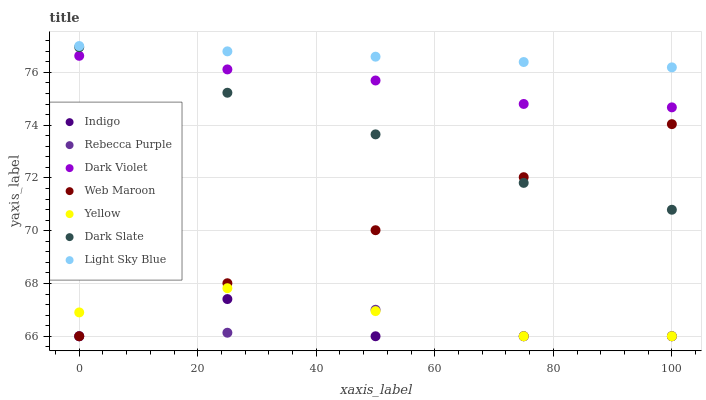Does Rebecca Purple have the minimum area under the curve?
Answer yes or no. Yes. Does Light Sky Blue have the maximum area under the curve?
Answer yes or no. Yes. Does Dark Violet have the minimum area under the curve?
Answer yes or no. No. Does Dark Violet have the maximum area under the curve?
Answer yes or no. No. Is Light Sky Blue the smoothest?
Answer yes or no. Yes. Is Indigo the roughest?
Answer yes or no. Yes. Is Dark Violet the smoothest?
Answer yes or no. No. Is Dark Violet the roughest?
Answer yes or no. No. Does Indigo have the lowest value?
Answer yes or no. Yes. Does Dark Violet have the lowest value?
Answer yes or no. No. Does Light Sky Blue have the highest value?
Answer yes or no. Yes. Does Dark Violet have the highest value?
Answer yes or no. No. Is Yellow less than Light Sky Blue?
Answer yes or no. Yes. Is Light Sky Blue greater than Dark Slate?
Answer yes or no. Yes. Does Rebecca Purple intersect Indigo?
Answer yes or no. Yes. Is Rebecca Purple less than Indigo?
Answer yes or no. No. Is Rebecca Purple greater than Indigo?
Answer yes or no. No. Does Yellow intersect Light Sky Blue?
Answer yes or no. No. 